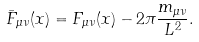Convert formula to latex. <formula><loc_0><loc_0><loc_500><loc_500>\bar { F } _ { \mu \nu } ( x ) = F _ { \mu \nu } ( x ) - 2 \pi \frac { m _ { \mu \nu } } { L ^ { 2 } } .</formula> 